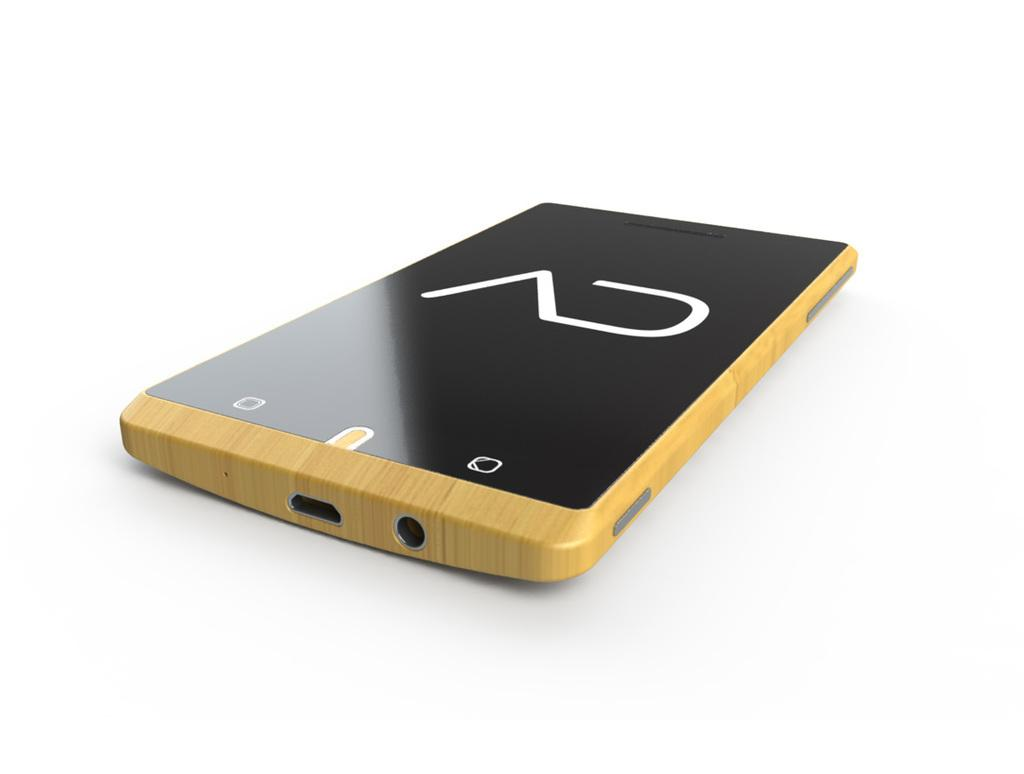What object is the main focus of the image? There is a phone in the image. What color is the background of the image? The background of the image is white. What type of bait is being used to catch fish in the image? There is no mention of fish or bait in the image; it only features a phone. 